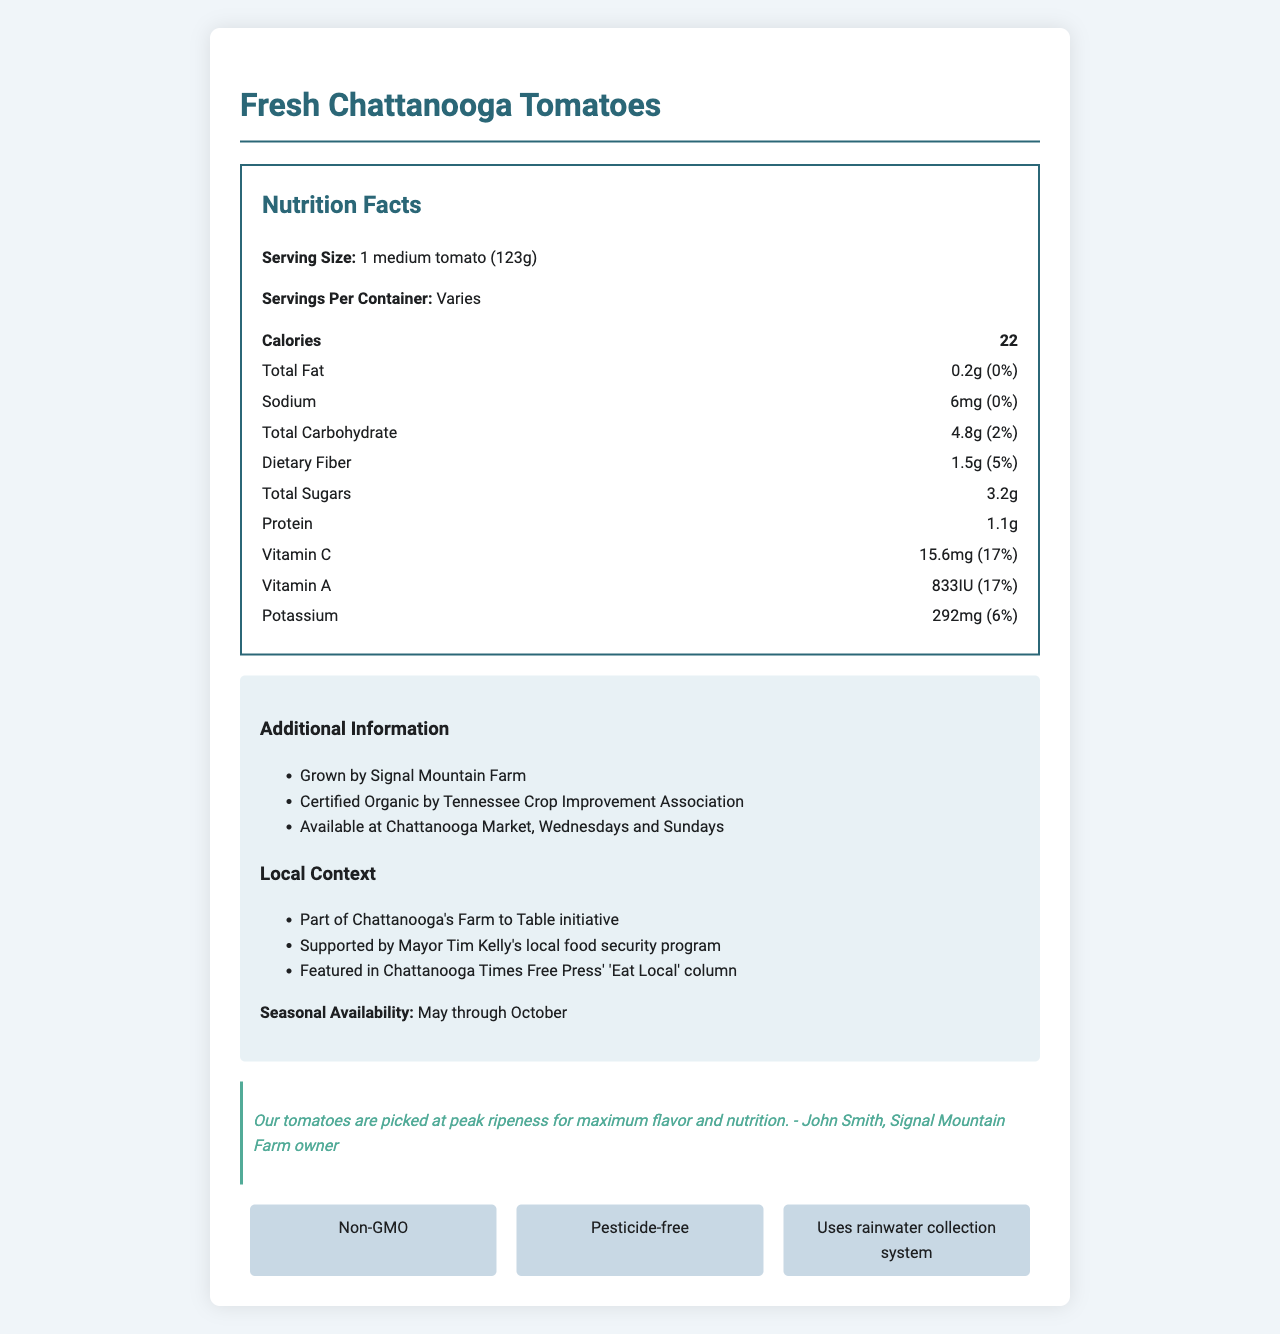what is the serving size for Fresh Chattanooga Tomatoes? The document explicitly states that the serving size for Fresh Chattanooga Tomatoes is "1 medium tomato (123g)".
Answer: 1 medium tomato (123g) what is the calorie content per serving? According to the document, each serving of Fresh Chattanooga Tomatoes contains 22 calories.
Answer: 22 calories how much dietary fiber is in one serving? The nutrition label indicates that one serving of Fresh Chattanooga Tomatoes contains 1.5 grams of dietary fiber.
Answer: 1.5g which farm grows the Fresh Chattanooga Tomatoes? The additional information section mentions that the tomatoes are grown by Signal Mountain Farm.
Answer: Signal Mountain Farm how much potassium is in one serving? The document lists the potassium content as 292mg per serving.
Answer: 292mg where can Fresh Chattanooga Tomatoes be purchased? The additional information states that these tomatoes are available at Chattanooga Market on Wednesdays and Sundays.
Answer: Chattanooga Market, Wednesdays and Sundays what is the daily value percentage of Vitamin C per serving? The nutrition facts label indicates that each serving provides 17% of the daily value of Vitamin C.
Answer: 17% what certification does the produce have? A. USDA Organic B. Certified Organic by Tennessee Crop Improvement Association C. Organic Farmers Association D. Certified Local Farm Produce The document specifies that the produce is Certified Organic by Tennessee Crop Improvement Association.
Answer: B. Certified Organic by Tennessee Crop Improvement Association during which months are Fresh Chattanooga Tomatoes available? A. April to September B. May to October C. June to November D. March to August Seasonal availability is listed as May through October in the document.
Answer: B. May to October what statement best reflects the farmer’s view on their produce? A. “Our tomatoes are affordable and widely available.” B. “We ensure that every tomato is pesticide-free and healthy.” C. “Our tomatoes are picked at peak ripeness for maximum flavor and nutrition.” D. “We use advanced farming techniques to ensure year-round supply.” A quote from John Smith, the farm owner, says: “Our tomatoes are picked at peak ripeness for maximum flavor and nutrition.”
Answer: C. “Our tomatoes are picked at peak ripeness for maximum flavor and nutrition.” do Fresh Chattanooga Tomatoes contain any fat? The nutrition label shows that there is 0.2g of total fat per serving, which rounds to 0% of daily value, but still indicates that fat is present.
Answer: Yes summarize the document The document gives an overview of the nutritional benefits and local significance of Fresh Chattanooga Tomatoes, their availability, and the sustainable methods used in their cultivation.
Answer: The document provides detailed nutrition facts for Fresh Chattanooga Tomatoes, including serving size, calories, and nutrient content. It highlights additional information such as the farm where they are grown (Signal Mountain Farm), organic certification, and availability at the Chattanooga Market. The document emphasizes the local context and sustainable farming practices while also featuring a quote from the farm owner about the quality of the produce. how many servings are in a container? The document states that servings per container vary; therefore, it does not provide a specific number of servings per container.
Answer: Cannot be determined 